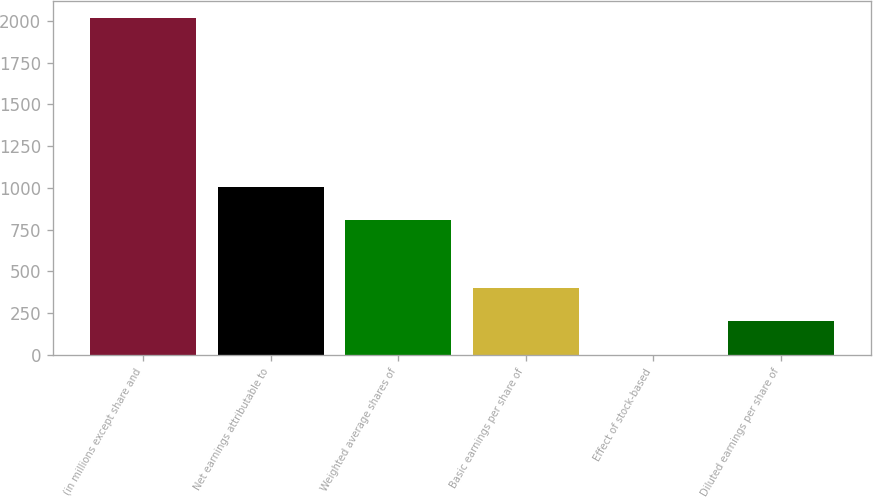<chart> <loc_0><loc_0><loc_500><loc_500><bar_chart><fcel>(in millions except share and<fcel>Net earnings attributable to<fcel>Weighted average shares of<fcel>Basic earnings per share of<fcel>Effect of stock-based<fcel>Diluted earnings per share of<nl><fcel>2016<fcel>1008.47<fcel>806.96<fcel>403.95<fcel>0.95<fcel>202.45<nl></chart> 